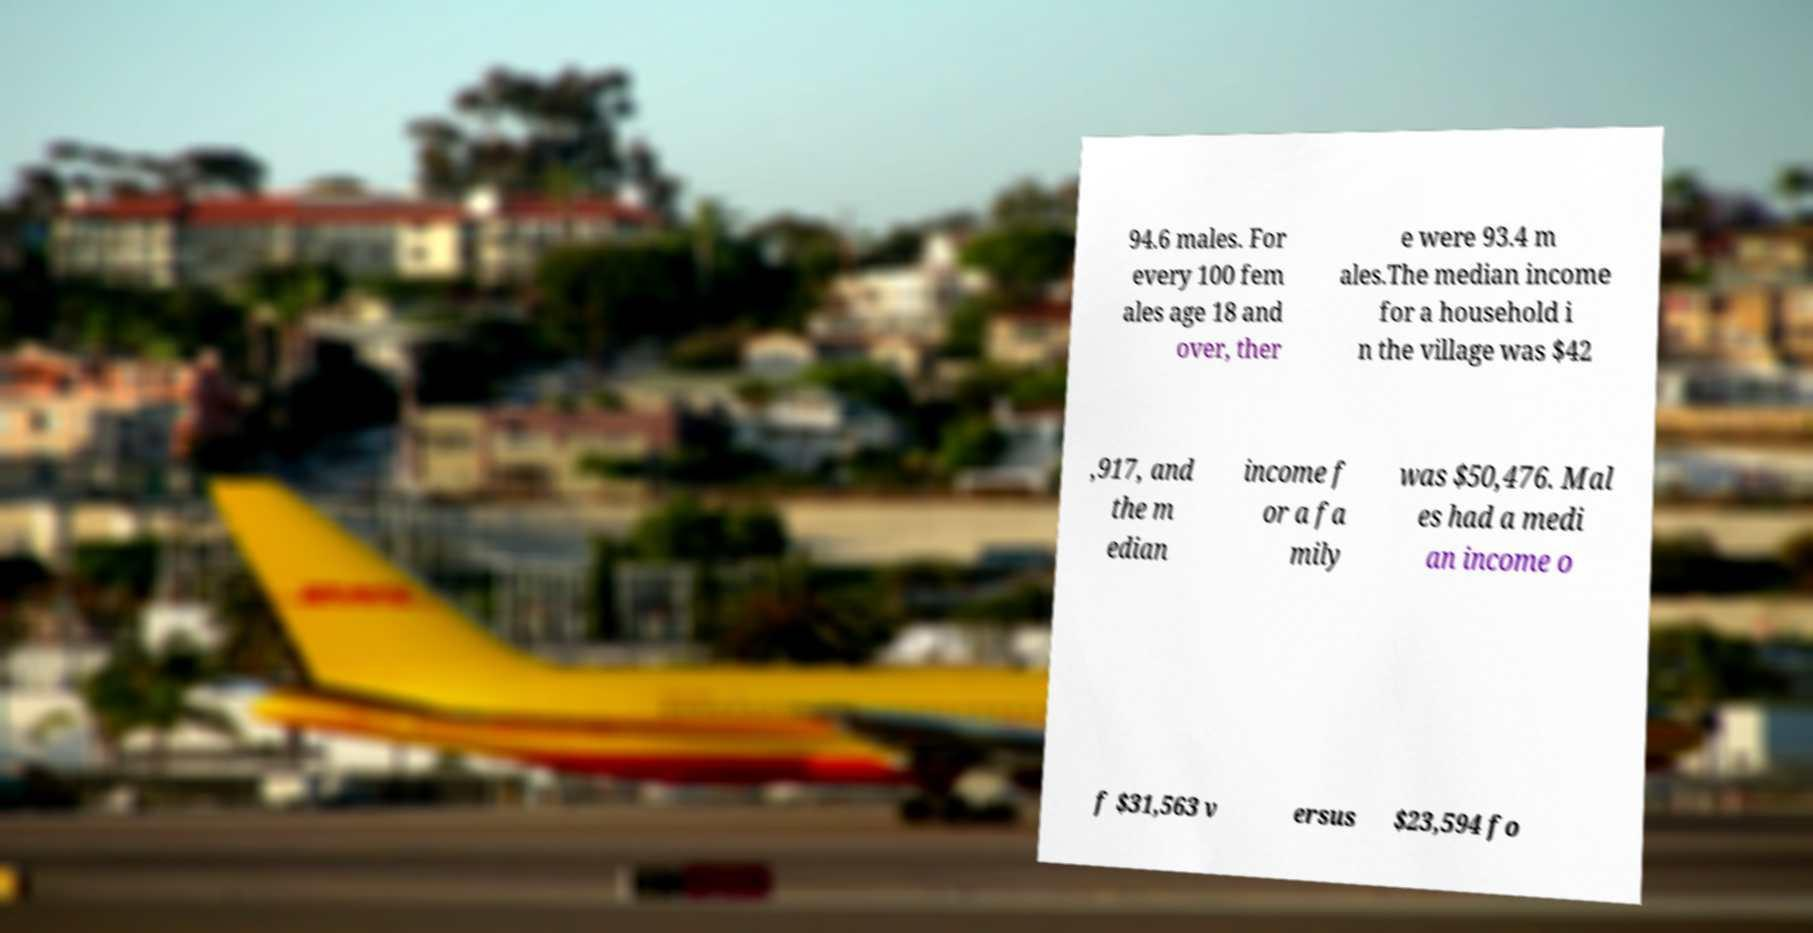Could you assist in decoding the text presented in this image and type it out clearly? 94.6 males. For every 100 fem ales age 18 and over, ther e were 93.4 m ales.The median income for a household i n the village was $42 ,917, and the m edian income f or a fa mily was $50,476. Mal es had a medi an income o f $31,563 v ersus $23,594 fo 